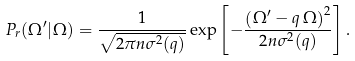Convert formula to latex. <formula><loc_0><loc_0><loc_500><loc_500>P _ { r } ( \Omega ^ { \prime } | \Omega ) = \frac { 1 } { \sqrt { 2 \pi n \sigma ^ { 2 } ( q ) } } \exp \left [ - \frac { \left ( \Omega ^ { \prime } - q \, \Omega \right ) ^ { 2 } } { 2 n \sigma ^ { 2 } ( q ) } \right ] .</formula> 